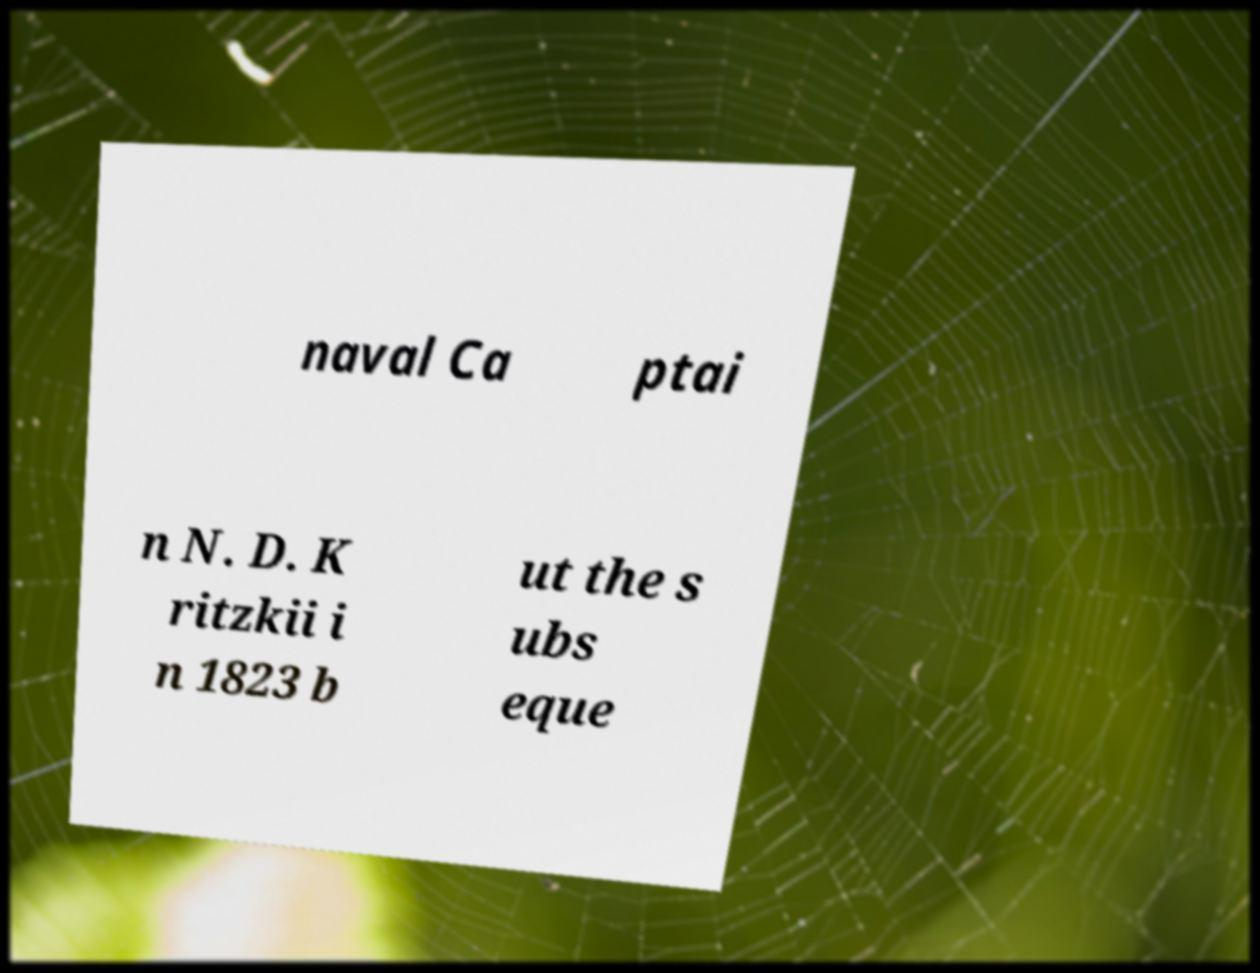What messages or text are displayed in this image? I need them in a readable, typed format. naval Ca ptai n N. D. K ritzkii i n 1823 b ut the s ubs eque 